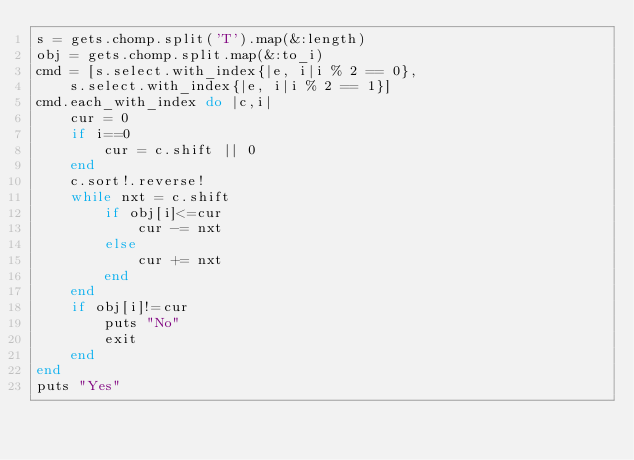<code> <loc_0><loc_0><loc_500><loc_500><_Ruby_>s = gets.chomp.split('T').map(&:length)
obj = gets.chomp.split.map(&:to_i)
cmd = [s.select.with_index{|e, i|i % 2 == 0},
	s.select.with_index{|e, i|i % 2 == 1}]
cmd.each_with_index do |c,i|
	cur = 0
	if i==0
		cur = c.shift || 0
	end
	c.sort!.reverse!
	while nxt = c.shift
		if obj[i]<=cur
			cur -= nxt
		else
			cur += nxt
		end
	end
	if obj[i]!=cur
		puts "No"
		exit
	end
end
puts "Yes"</code> 